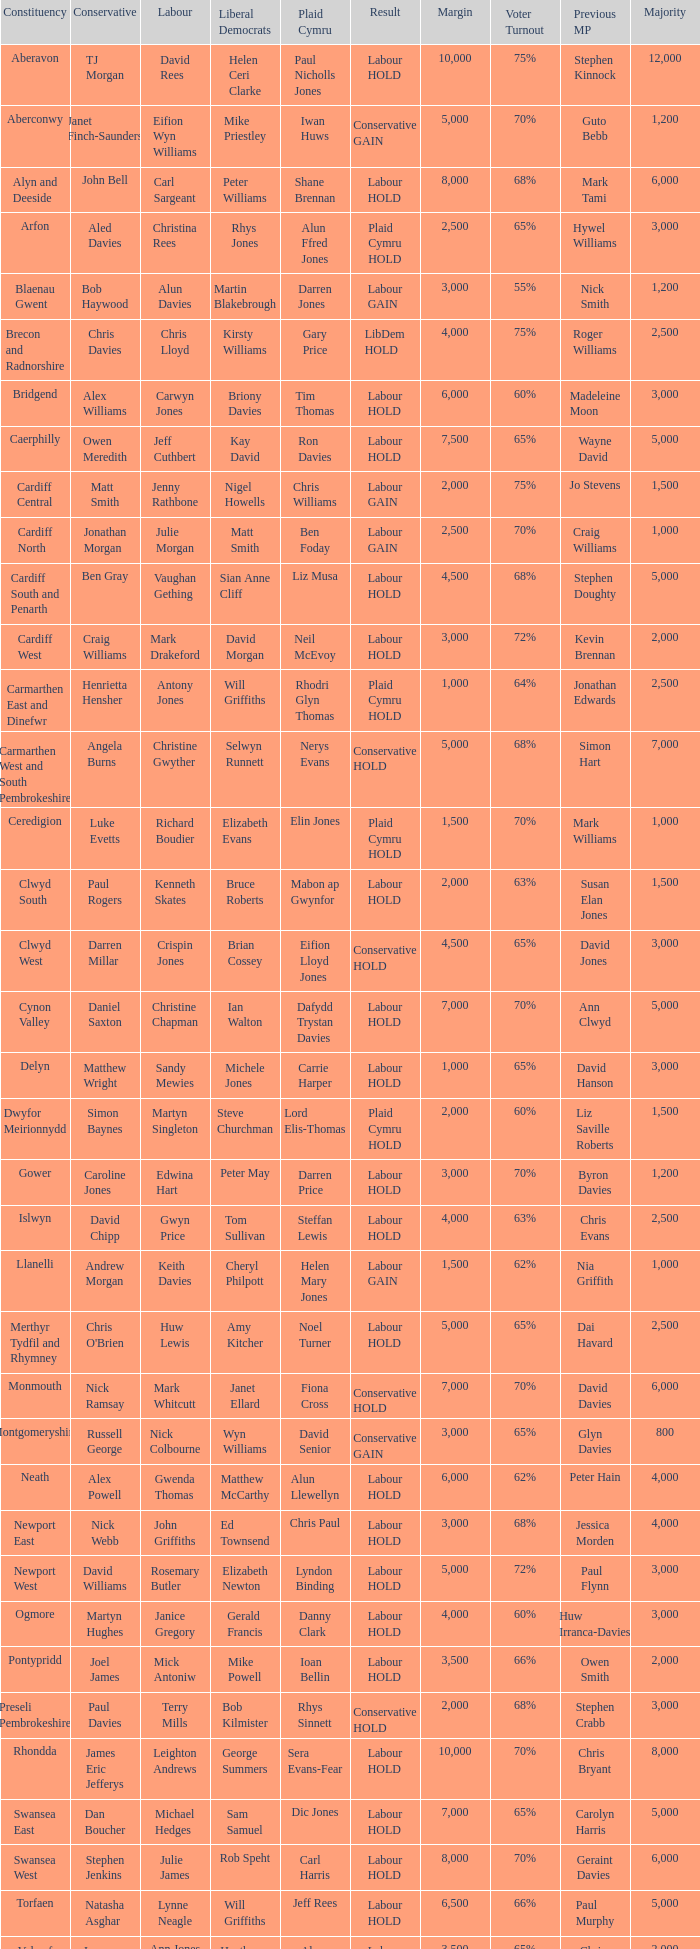In what constituency was the result labour hold and Liberal democrat Elizabeth Newton won? Newport West. 